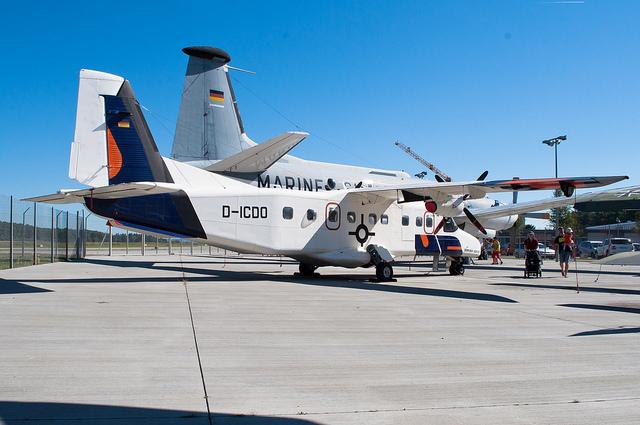What branch of the military is represented on the far plane?
Give a very brief answer. Marines. How many planes do you see?
Write a very short answer. 2. What is the weather like?
Quick response, please. Sunny. What is the weather?
Short answer required. Sunny. What kind of vehicle can be seen?
Write a very short answer. Planes. 